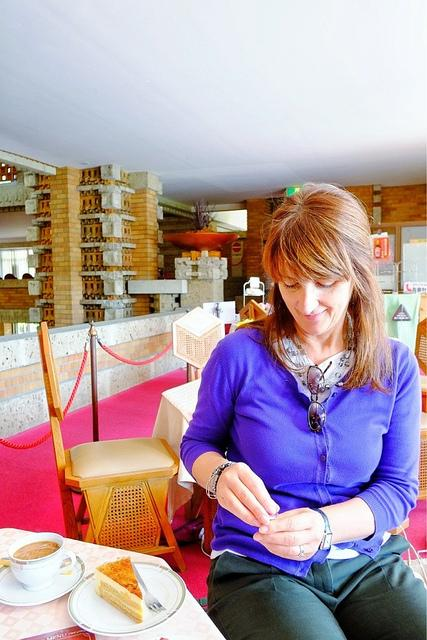Why is the woman sitting?

Choices:
A) to eat
B) tie shoes
C) have conversation
D) to work to eat 